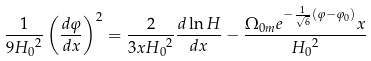Convert formula to latex. <formula><loc_0><loc_0><loc_500><loc_500>\frac { 1 } { 9 { H _ { 0 } } ^ { 2 } } \left ( { \frac { d \varphi } { d x } } \right ) ^ { 2 } = \frac { 2 } { 3 x { H _ { 0 } } ^ { 2 } } \frac { d \ln H } { d x } - \frac { \Omega _ { 0 m } e ^ { - \frac { 1 } { \sqrt { 6 } } ( \varphi - \varphi _ { 0 } ) } x } { { H _ { 0 } } ^ { 2 } }</formula> 